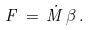Convert formula to latex. <formula><loc_0><loc_0><loc_500><loc_500>F \, = \, { \dot { M } } \, \beta \, .</formula> 